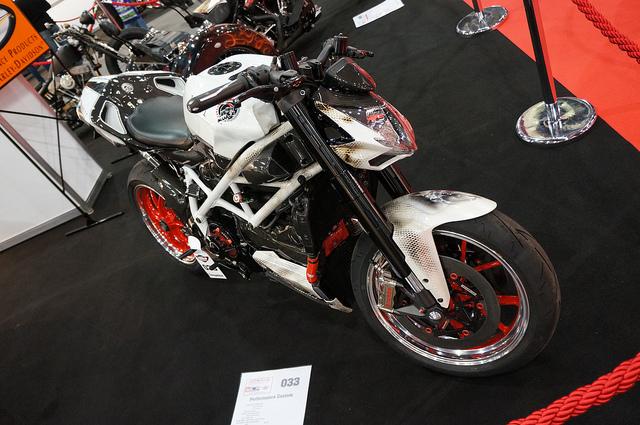How many ropes do you see?
Give a very brief answer. 2. What kind of bike is this?
Answer briefly. Motorcycle. What color are the insides of the tires?
Keep it brief. Red. 